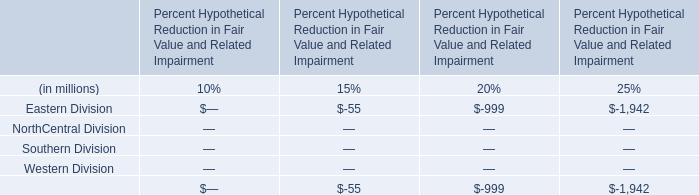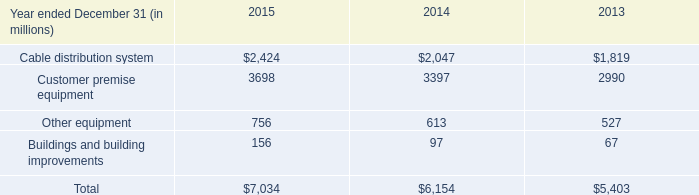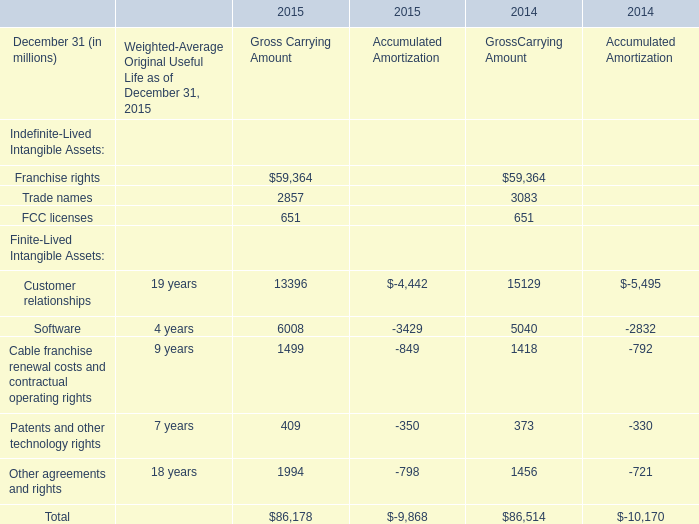What is the average amount of Trade names of 2014 GrossCarrying Amount, and Cable distribution system of 2014 ? 
Computations: ((3083.0 + 2047.0) / 2)
Answer: 2565.0. 